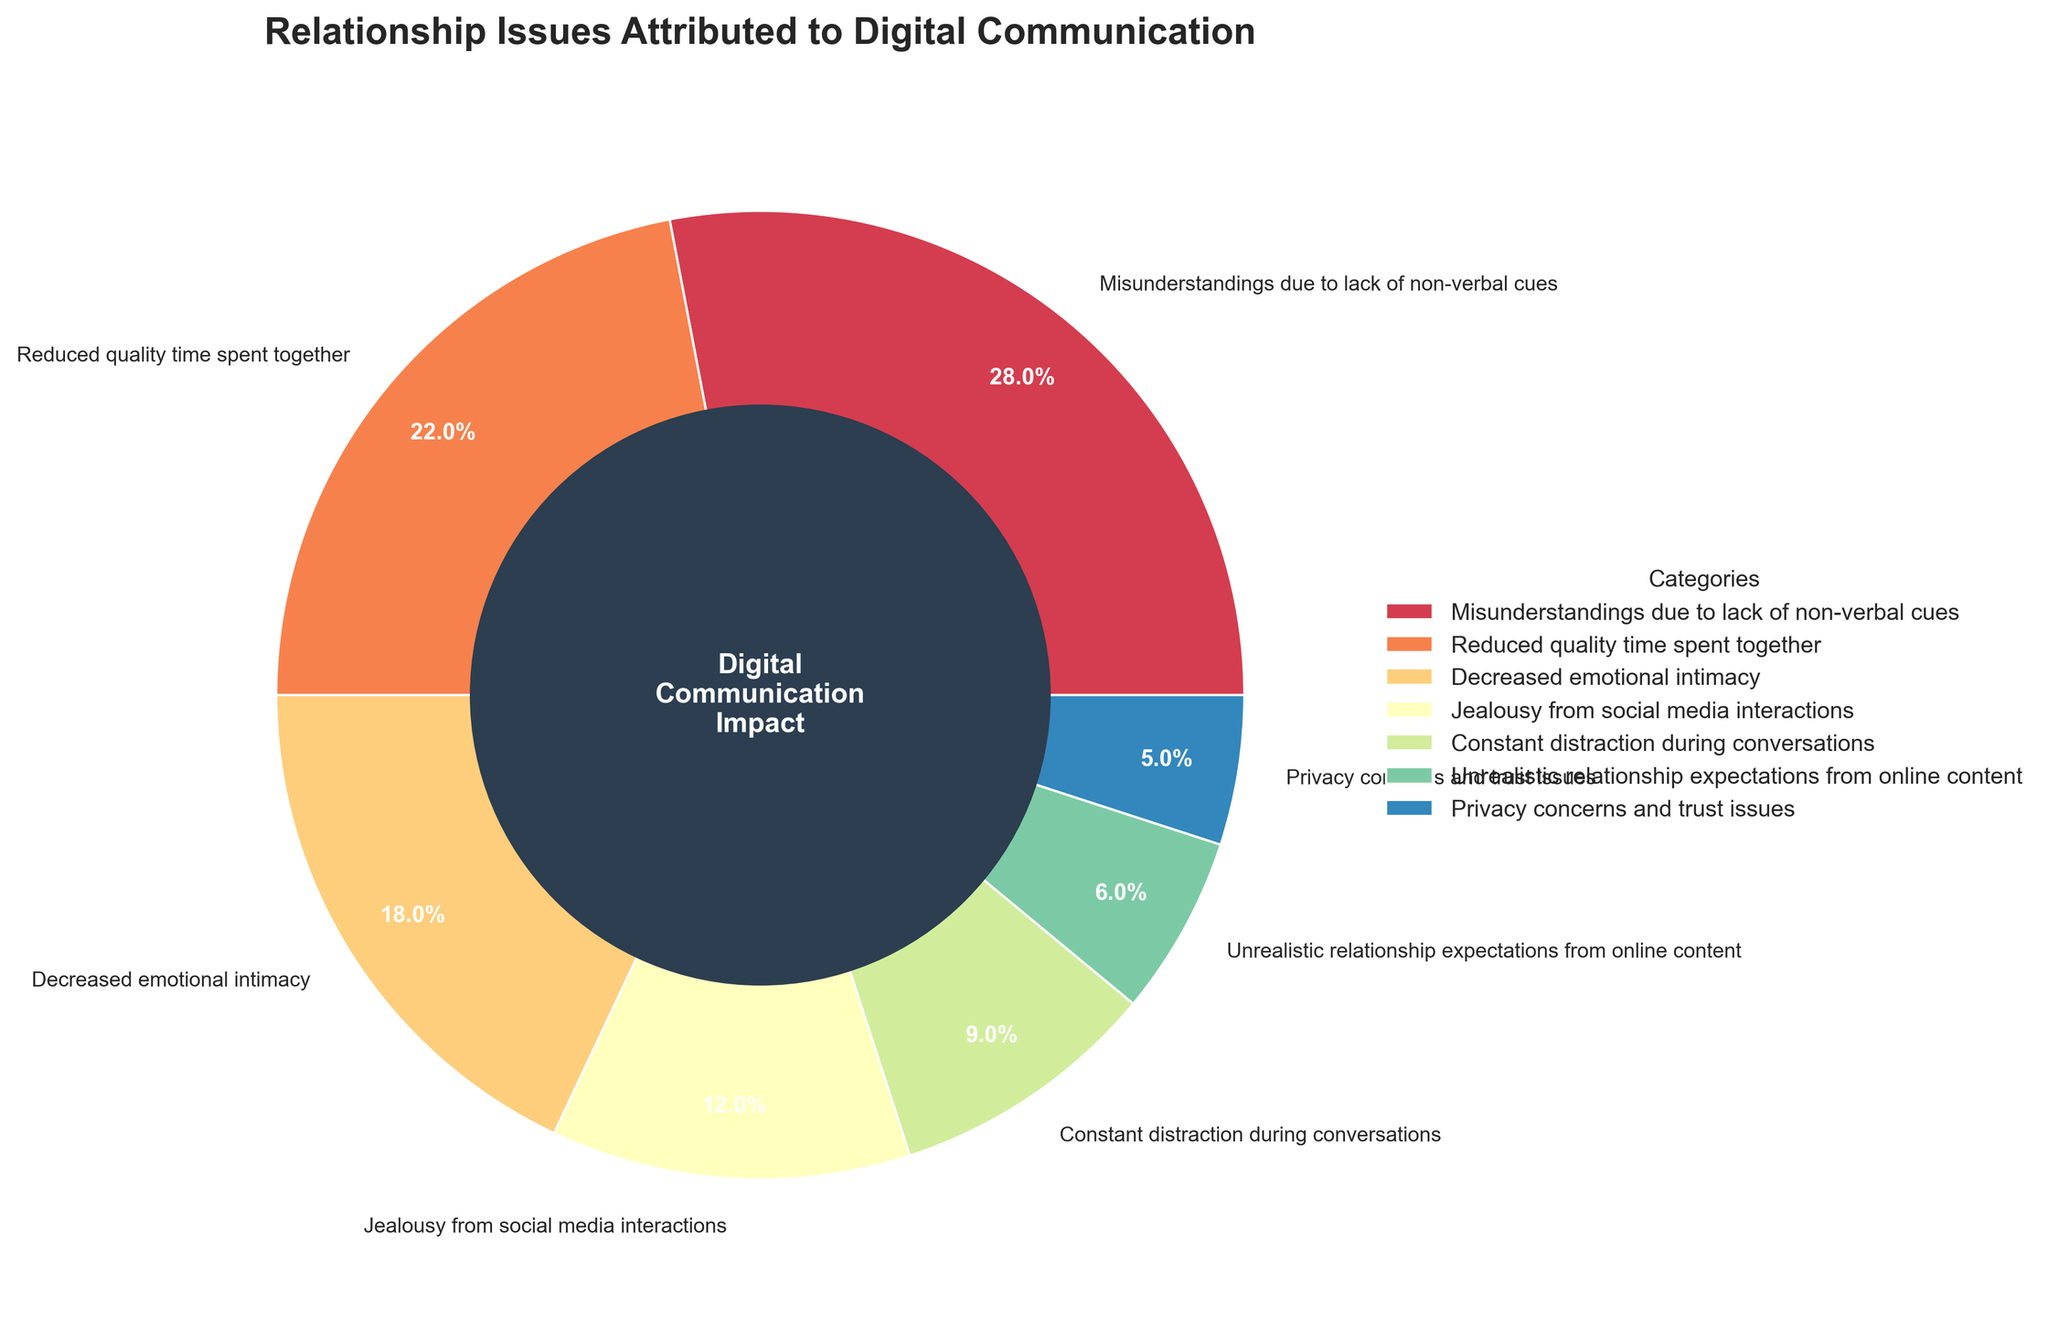What percentage of relationship issues are attributed to reduced quality time spent together due to digital communication? The figure shows a pie chart labeled with different categories and percentages. The segment labeled 'Reduced quality time spent together' shows a percentage value directly in the figure.
Answer: 22% What category represents the largest percentage of reported relationship issues? By looking at the sizes of the segments in the pie chart and the labels, the largest segment is labeled 'Misunderstandings due to lack of non-verbal cues', indicating it represents the largest percentage.
Answer: Misunderstandings due to lack of non-verbal cues Which issue related to digital communication constitutes 9% of reported relationship issues? The pie chart has a segment labeled 'Constant distraction during conversations' which indicates it accounts for 9% of the relationship issues.
Answer: Constant distraction during conversations What is the total percentage of reported relationship issues attributed to digital communication, from categories with less than 10% each? Summing the percentages of the categories with less than 10%: Constant distraction during conversations (9%), Unrealistic relationship expectations from online content (6%), and Privacy concerns and trust issues (5%). 9 + 6 + 5 = 20
Answer: 20% How does the percentage of 'Jealousy from social media interactions' compare to 'Decreased emotional intimacy'? The pie chart shows 'Jealousy from social media interactions' as 12% and 'Decreased emotional intimacy' as 18%. 12% is less than 18%, showing that jealousy due to social media interactions is lower.
Answer: Less What is the combined percentage of 'Privacy concerns and trust issues' and 'Unrealistic relationship expectations from online content'? Adding the percentages of these two categories from the pie chart: Privacy concerns and trust issues (5%) and Unrealistic relationship expectations from online content (6%). 5 + 6 = 11
Answer: 11% Which category has the smallest percentage representation on the pie chart? The category with the smallest segment in the pie chart, labeled with the lowest percentage, is 'Privacy concerns and trust issues' with 5%.
Answer: Privacy concerns and trust issues How much larger is the percentage for 'Reduced quality time spent together' compared to 'Privacy concerns and trust issues'? Subtract the percentage of Privacy concerns and trust issues (5%) from that of Reduced quality time spent together (22%). 22 - 5 = 17
Answer: 17% If the percentages for 'Misunderstandings due to lack of non-verbal cues' and 'Reduced quality time spent together' are combined, what is their total percentage? Adding the percentages from the pie chart: Misunderstandings due to lack of non-verbal cues (28%) and Reduced quality time spent together (22%). 28 + 22 = 50
Answer: 50% 